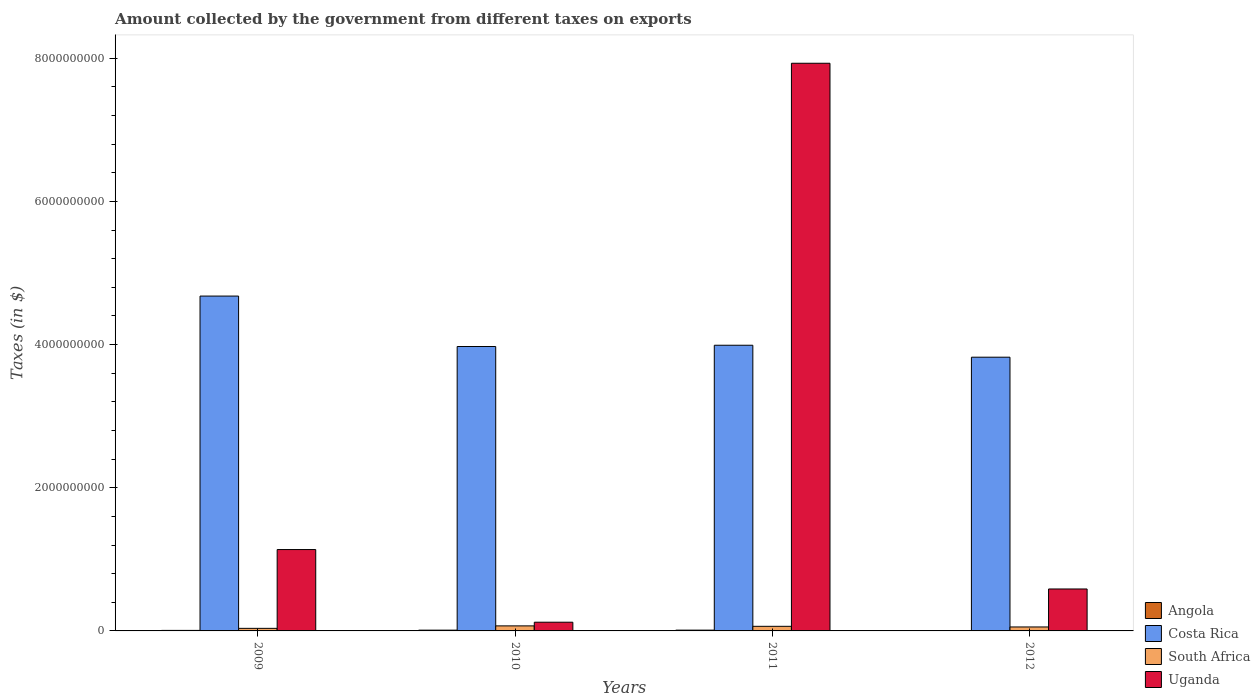How many groups of bars are there?
Offer a terse response. 4. Are the number of bars per tick equal to the number of legend labels?
Offer a very short reply. Yes. Are the number of bars on each tick of the X-axis equal?
Provide a succinct answer. Yes. How many bars are there on the 4th tick from the left?
Your response must be concise. 4. What is the label of the 2nd group of bars from the left?
Make the answer very short. 2010. In how many cases, is the number of bars for a given year not equal to the number of legend labels?
Keep it short and to the point. 0. What is the amount collected by the government from taxes on exports in South Africa in 2010?
Offer a very short reply. 7.04e+07. Across all years, what is the maximum amount collected by the government from taxes on exports in Angola?
Offer a very short reply. 1.11e+07. Across all years, what is the minimum amount collected by the government from taxes on exports in Angola?
Provide a short and direct response. 4.42e+05. In which year was the amount collected by the government from taxes on exports in South Africa maximum?
Ensure brevity in your answer.  2010. In which year was the amount collected by the government from taxes on exports in Angola minimum?
Keep it short and to the point. 2012. What is the total amount collected by the government from taxes on exports in Uganda in the graph?
Give a very brief answer. 9.77e+09. What is the difference between the amount collected by the government from taxes on exports in Costa Rica in 2009 and that in 2012?
Keep it short and to the point. 8.54e+08. What is the difference between the amount collected by the government from taxes on exports in South Africa in 2011 and the amount collected by the government from taxes on exports in Costa Rica in 2010?
Offer a terse response. -3.91e+09. What is the average amount collected by the government from taxes on exports in South Africa per year?
Provide a short and direct response. 5.65e+07. In the year 2009, what is the difference between the amount collected by the government from taxes on exports in Costa Rica and amount collected by the government from taxes on exports in South Africa?
Make the answer very short. 4.64e+09. In how many years, is the amount collected by the government from taxes on exports in Uganda greater than 5600000000 $?
Your answer should be compact. 1. What is the ratio of the amount collected by the government from taxes on exports in Uganda in 2010 to that in 2011?
Offer a very short reply. 0.02. What is the difference between the highest and the second highest amount collected by the government from taxes on exports in Angola?
Make the answer very short. 4.03e+05. What is the difference between the highest and the lowest amount collected by the government from taxes on exports in Costa Rica?
Your answer should be compact. 8.54e+08. Is it the case that in every year, the sum of the amount collected by the government from taxes on exports in Costa Rica and amount collected by the government from taxes on exports in South Africa is greater than the sum of amount collected by the government from taxes on exports in Angola and amount collected by the government from taxes on exports in Uganda?
Provide a short and direct response. Yes. What does the 1st bar from the left in 2011 represents?
Provide a short and direct response. Angola. What does the 1st bar from the right in 2012 represents?
Make the answer very short. Uganda. Are all the bars in the graph horizontal?
Your answer should be very brief. No. Are the values on the major ticks of Y-axis written in scientific E-notation?
Your response must be concise. No. Where does the legend appear in the graph?
Ensure brevity in your answer.  Bottom right. How many legend labels are there?
Provide a short and direct response. 4. How are the legend labels stacked?
Your answer should be very brief. Vertical. What is the title of the graph?
Your response must be concise. Amount collected by the government from different taxes on exports. What is the label or title of the Y-axis?
Offer a terse response. Taxes (in $). What is the Taxes (in $) of Angola in 2009?
Your answer should be very brief. 7.26e+06. What is the Taxes (in $) of Costa Rica in 2009?
Offer a terse response. 4.68e+09. What is the Taxes (in $) of South Africa in 2009?
Provide a succinct answer. 3.60e+07. What is the Taxes (in $) in Uganda in 2009?
Offer a terse response. 1.14e+09. What is the Taxes (in $) in Angola in 2010?
Offer a very short reply. 1.07e+07. What is the Taxes (in $) of Costa Rica in 2010?
Provide a short and direct response. 3.97e+09. What is the Taxes (in $) in South Africa in 2010?
Make the answer very short. 7.04e+07. What is the Taxes (in $) in Uganda in 2010?
Give a very brief answer. 1.22e+08. What is the Taxes (in $) of Angola in 2011?
Provide a short and direct response. 1.11e+07. What is the Taxes (in $) of Costa Rica in 2011?
Provide a succinct answer. 3.99e+09. What is the Taxes (in $) in South Africa in 2011?
Offer a very short reply. 6.42e+07. What is the Taxes (in $) in Uganda in 2011?
Make the answer very short. 7.93e+09. What is the Taxes (in $) of Angola in 2012?
Your answer should be compact. 4.42e+05. What is the Taxes (in $) of Costa Rica in 2012?
Your answer should be compact. 3.82e+09. What is the Taxes (in $) of South Africa in 2012?
Provide a short and direct response. 5.54e+07. What is the Taxes (in $) of Uganda in 2012?
Provide a short and direct response. 5.86e+08. Across all years, what is the maximum Taxes (in $) in Angola?
Your answer should be very brief. 1.11e+07. Across all years, what is the maximum Taxes (in $) of Costa Rica?
Provide a short and direct response. 4.68e+09. Across all years, what is the maximum Taxes (in $) in South Africa?
Your response must be concise. 7.04e+07. Across all years, what is the maximum Taxes (in $) in Uganda?
Keep it short and to the point. 7.93e+09. Across all years, what is the minimum Taxes (in $) in Angola?
Give a very brief answer. 4.42e+05. Across all years, what is the minimum Taxes (in $) of Costa Rica?
Offer a terse response. 3.82e+09. Across all years, what is the minimum Taxes (in $) of South Africa?
Keep it short and to the point. 3.60e+07. Across all years, what is the minimum Taxes (in $) of Uganda?
Your response must be concise. 1.22e+08. What is the total Taxes (in $) of Angola in the graph?
Provide a short and direct response. 2.95e+07. What is the total Taxes (in $) of Costa Rica in the graph?
Offer a terse response. 1.65e+1. What is the total Taxes (in $) in South Africa in the graph?
Keep it short and to the point. 2.26e+08. What is the total Taxes (in $) in Uganda in the graph?
Your response must be concise. 9.77e+09. What is the difference between the Taxes (in $) of Angola in 2009 and that in 2010?
Offer a terse response. -3.46e+06. What is the difference between the Taxes (in $) of Costa Rica in 2009 and that in 2010?
Make the answer very short. 7.04e+08. What is the difference between the Taxes (in $) of South Africa in 2009 and that in 2010?
Keep it short and to the point. -3.44e+07. What is the difference between the Taxes (in $) of Uganda in 2009 and that in 2010?
Your answer should be very brief. 1.01e+09. What is the difference between the Taxes (in $) of Angola in 2009 and that in 2011?
Your response must be concise. -3.86e+06. What is the difference between the Taxes (in $) of Costa Rica in 2009 and that in 2011?
Provide a succinct answer. 6.87e+08. What is the difference between the Taxes (in $) in South Africa in 2009 and that in 2011?
Offer a very short reply. -2.82e+07. What is the difference between the Taxes (in $) in Uganda in 2009 and that in 2011?
Provide a succinct answer. -6.79e+09. What is the difference between the Taxes (in $) in Angola in 2009 and that in 2012?
Offer a terse response. 6.82e+06. What is the difference between the Taxes (in $) in Costa Rica in 2009 and that in 2012?
Make the answer very short. 8.54e+08. What is the difference between the Taxes (in $) in South Africa in 2009 and that in 2012?
Your response must be concise. -1.94e+07. What is the difference between the Taxes (in $) in Uganda in 2009 and that in 2012?
Your answer should be very brief. 5.51e+08. What is the difference between the Taxes (in $) of Angola in 2010 and that in 2011?
Ensure brevity in your answer.  -4.03e+05. What is the difference between the Taxes (in $) of Costa Rica in 2010 and that in 2011?
Your response must be concise. -1.76e+07. What is the difference between the Taxes (in $) in South Africa in 2010 and that in 2011?
Provide a succinct answer. 6.16e+06. What is the difference between the Taxes (in $) in Uganda in 2010 and that in 2011?
Your response must be concise. -7.81e+09. What is the difference between the Taxes (in $) in Angola in 2010 and that in 2012?
Your answer should be compact. 1.03e+07. What is the difference between the Taxes (in $) in Costa Rica in 2010 and that in 2012?
Your answer should be very brief. 1.49e+08. What is the difference between the Taxes (in $) in South Africa in 2010 and that in 2012?
Give a very brief answer. 1.50e+07. What is the difference between the Taxes (in $) in Uganda in 2010 and that in 2012?
Provide a short and direct response. -4.64e+08. What is the difference between the Taxes (in $) in Angola in 2011 and that in 2012?
Give a very brief answer. 1.07e+07. What is the difference between the Taxes (in $) of Costa Rica in 2011 and that in 2012?
Ensure brevity in your answer.  1.67e+08. What is the difference between the Taxes (in $) in South Africa in 2011 and that in 2012?
Your response must be concise. 8.85e+06. What is the difference between the Taxes (in $) of Uganda in 2011 and that in 2012?
Your response must be concise. 7.34e+09. What is the difference between the Taxes (in $) in Angola in 2009 and the Taxes (in $) in Costa Rica in 2010?
Provide a short and direct response. -3.97e+09. What is the difference between the Taxes (in $) in Angola in 2009 and the Taxes (in $) in South Africa in 2010?
Ensure brevity in your answer.  -6.31e+07. What is the difference between the Taxes (in $) of Angola in 2009 and the Taxes (in $) of Uganda in 2010?
Offer a very short reply. -1.15e+08. What is the difference between the Taxes (in $) of Costa Rica in 2009 and the Taxes (in $) of South Africa in 2010?
Provide a succinct answer. 4.61e+09. What is the difference between the Taxes (in $) in Costa Rica in 2009 and the Taxes (in $) in Uganda in 2010?
Provide a succinct answer. 4.56e+09. What is the difference between the Taxes (in $) of South Africa in 2009 and the Taxes (in $) of Uganda in 2010?
Ensure brevity in your answer.  -8.58e+07. What is the difference between the Taxes (in $) of Angola in 2009 and the Taxes (in $) of Costa Rica in 2011?
Offer a terse response. -3.98e+09. What is the difference between the Taxes (in $) of Angola in 2009 and the Taxes (in $) of South Africa in 2011?
Your answer should be compact. -5.70e+07. What is the difference between the Taxes (in $) in Angola in 2009 and the Taxes (in $) in Uganda in 2011?
Provide a short and direct response. -7.92e+09. What is the difference between the Taxes (in $) in Costa Rica in 2009 and the Taxes (in $) in South Africa in 2011?
Offer a very short reply. 4.61e+09. What is the difference between the Taxes (in $) of Costa Rica in 2009 and the Taxes (in $) of Uganda in 2011?
Offer a terse response. -3.25e+09. What is the difference between the Taxes (in $) in South Africa in 2009 and the Taxes (in $) in Uganda in 2011?
Give a very brief answer. -7.89e+09. What is the difference between the Taxes (in $) of Angola in 2009 and the Taxes (in $) of Costa Rica in 2012?
Offer a very short reply. -3.82e+09. What is the difference between the Taxes (in $) of Angola in 2009 and the Taxes (in $) of South Africa in 2012?
Provide a succinct answer. -4.81e+07. What is the difference between the Taxes (in $) of Angola in 2009 and the Taxes (in $) of Uganda in 2012?
Offer a very short reply. -5.79e+08. What is the difference between the Taxes (in $) in Costa Rica in 2009 and the Taxes (in $) in South Africa in 2012?
Ensure brevity in your answer.  4.62e+09. What is the difference between the Taxes (in $) in Costa Rica in 2009 and the Taxes (in $) in Uganda in 2012?
Your answer should be very brief. 4.09e+09. What is the difference between the Taxes (in $) of South Africa in 2009 and the Taxes (in $) of Uganda in 2012?
Make the answer very short. -5.50e+08. What is the difference between the Taxes (in $) of Angola in 2010 and the Taxes (in $) of Costa Rica in 2011?
Keep it short and to the point. -3.98e+09. What is the difference between the Taxes (in $) of Angola in 2010 and the Taxes (in $) of South Africa in 2011?
Offer a very short reply. -5.35e+07. What is the difference between the Taxes (in $) of Angola in 2010 and the Taxes (in $) of Uganda in 2011?
Provide a short and direct response. -7.92e+09. What is the difference between the Taxes (in $) of Costa Rica in 2010 and the Taxes (in $) of South Africa in 2011?
Give a very brief answer. 3.91e+09. What is the difference between the Taxes (in $) in Costa Rica in 2010 and the Taxes (in $) in Uganda in 2011?
Your response must be concise. -3.96e+09. What is the difference between the Taxes (in $) of South Africa in 2010 and the Taxes (in $) of Uganda in 2011?
Offer a terse response. -7.86e+09. What is the difference between the Taxes (in $) in Angola in 2010 and the Taxes (in $) in Costa Rica in 2012?
Your answer should be compact. -3.81e+09. What is the difference between the Taxes (in $) of Angola in 2010 and the Taxes (in $) of South Africa in 2012?
Your response must be concise. -4.47e+07. What is the difference between the Taxes (in $) of Angola in 2010 and the Taxes (in $) of Uganda in 2012?
Provide a short and direct response. -5.75e+08. What is the difference between the Taxes (in $) in Costa Rica in 2010 and the Taxes (in $) in South Africa in 2012?
Provide a short and direct response. 3.92e+09. What is the difference between the Taxes (in $) of Costa Rica in 2010 and the Taxes (in $) of Uganda in 2012?
Offer a terse response. 3.39e+09. What is the difference between the Taxes (in $) in South Africa in 2010 and the Taxes (in $) in Uganda in 2012?
Offer a terse response. -5.16e+08. What is the difference between the Taxes (in $) of Angola in 2011 and the Taxes (in $) of Costa Rica in 2012?
Make the answer very short. -3.81e+09. What is the difference between the Taxes (in $) of Angola in 2011 and the Taxes (in $) of South Africa in 2012?
Provide a succinct answer. -4.43e+07. What is the difference between the Taxes (in $) in Angola in 2011 and the Taxes (in $) in Uganda in 2012?
Offer a very short reply. -5.75e+08. What is the difference between the Taxes (in $) in Costa Rica in 2011 and the Taxes (in $) in South Africa in 2012?
Ensure brevity in your answer.  3.94e+09. What is the difference between the Taxes (in $) of Costa Rica in 2011 and the Taxes (in $) of Uganda in 2012?
Your answer should be very brief. 3.40e+09. What is the difference between the Taxes (in $) of South Africa in 2011 and the Taxes (in $) of Uganda in 2012?
Ensure brevity in your answer.  -5.22e+08. What is the average Taxes (in $) in Angola per year?
Your answer should be compact. 7.38e+06. What is the average Taxes (in $) in Costa Rica per year?
Provide a succinct answer. 4.12e+09. What is the average Taxes (in $) of South Africa per year?
Your response must be concise. 5.65e+07. What is the average Taxes (in $) in Uganda per year?
Your answer should be very brief. 2.44e+09. In the year 2009, what is the difference between the Taxes (in $) of Angola and Taxes (in $) of Costa Rica?
Give a very brief answer. -4.67e+09. In the year 2009, what is the difference between the Taxes (in $) of Angola and Taxes (in $) of South Africa?
Offer a very short reply. -2.87e+07. In the year 2009, what is the difference between the Taxes (in $) in Angola and Taxes (in $) in Uganda?
Offer a terse response. -1.13e+09. In the year 2009, what is the difference between the Taxes (in $) in Costa Rica and Taxes (in $) in South Africa?
Your answer should be very brief. 4.64e+09. In the year 2009, what is the difference between the Taxes (in $) of Costa Rica and Taxes (in $) of Uganda?
Your response must be concise. 3.54e+09. In the year 2009, what is the difference between the Taxes (in $) in South Africa and Taxes (in $) in Uganda?
Make the answer very short. -1.10e+09. In the year 2010, what is the difference between the Taxes (in $) of Angola and Taxes (in $) of Costa Rica?
Your response must be concise. -3.96e+09. In the year 2010, what is the difference between the Taxes (in $) of Angola and Taxes (in $) of South Africa?
Provide a short and direct response. -5.97e+07. In the year 2010, what is the difference between the Taxes (in $) in Angola and Taxes (in $) in Uganda?
Your response must be concise. -1.11e+08. In the year 2010, what is the difference between the Taxes (in $) in Costa Rica and Taxes (in $) in South Africa?
Keep it short and to the point. 3.90e+09. In the year 2010, what is the difference between the Taxes (in $) of Costa Rica and Taxes (in $) of Uganda?
Offer a terse response. 3.85e+09. In the year 2010, what is the difference between the Taxes (in $) of South Africa and Taxes (in $) of Uganda?
Your answer should be compact. -5.14e+07. In the year 2011, what is the difference between the Taxes (in $) of Angola and Taxes (in $) of Costa Rica?
Ensure brevity in your answer.  -3.98e+09. In the year 2011, what is the difference between the Taxes (in $) in Angola and Taxes (in $) in South Africa?
Provide a short and direct response. -5.31e+07. In the year 2011, what is the difference between the Taxes (in $) of Angola and Taxes (in $) of Uganda?
Your answer should be compact. -7.92e+09. In the year 2011, what is the difference between the Taxes (in $) of Costa Rica and Taxes (in $) of South Africa?
Your answer should be compact. 3.93e+09. In the year 2011, what is the difference between the Taxes (in $) in Costa Rica and Taxes (in $) in Uganda?
Offer a very short reply. -3.94e+09. In the year 2011, what is the difference between the Taxes (in $) of South Africa and Taxes (in $) of Uganda?
Make the answer very short. -7.87e+09. In the year 2012, what is the difference between the Taxes (in $) in Angola and Taxes (in $) in Costa Rica?
Offer a very short reply. -3.82e+09. In the year 2012, what is the difference between the Taxes (in $) in Angola and Taxes (in $) in South Africa?
Keep it short and to the point. -5.49e+07. In the year 2012, what is the difference between the Taxes (in $) of Angola and Taxes (in $) of Uganda?
Make the answer very short. -5.85e+08. In the year 2012, what is the difference between the Taxes (in $) of Costa Rica and Taxes (in $) of South Africa?
Your answer should be very brief. 3.77e+09. In the year 2012, what is the difference between the Taxes (in $) of Costa Rica and Taxes (in $) of Uganda?
Your response must be concise. 3.24e+09. In the year 2012, what is the difference between the Taxes (in $) in South Africa and Taxes (in $) in Uganda?
Your response must be concise. -5.31e+08. What is the ratio of the Taxes (in $) in Angola in 2009 to that in 2010?
Keep it short and to the point. 0.68. What is the ratio of the Taxes (in $) in Costa Rica in 2009 to that in 2010?
Make the answer very short. 1.18. What is the ratio of the Taxes (in $) in South Africa in 2009 to that in 2010?
Make the answer very short. 0.51. What is the ratio of the Taxes (in $) in Uganda in 2009 to that in 2010?
Give a very brief answer. 9.33. What is the ratio of the Taxes (in $) in Angola in 2009 to that in 2011?
Offer a very short reply. 0.65. What is the ratio of the Taxes (in $) of Costa Rica in 2009 to that in 2011?
Your response must be concise. 1.17. What is the ratio of the Taxes (in $) of South Africa in 2009 to that in 2011?
Provide a succinct answer. 0.56. What is the ratio of the Taxes (in $) of Uganda in 2009 to that in 2011?
Make the answer very short. 0.14. What is the ratio of the Taxes (in $) in Angola in 2009 to that in 2012?
Your response must be concise. 16.42. What is the ratio of the Taxes (in $) of Costa Rica in 2009 to that in 2012?
Provide a succinct answer. 1.22. What is the ratio of the Taxes (in $) of South Africa in 2009 to that in 2012?
Ensure brevity in your answer.  0.65. What is the ratio of the Taxes (in $) in Uganda in 2009 to that in 2012?
Make the answer very short. 1.94. What is the ratio of the Taxes (in $) in Angola in 2010 to that in 2011?
Your response must be concise. 0.96. What is the ratio of the Taxes (in $) in South Africa in 2010 to that in 2011?
Your response must be concise. 1.1. What is the ratio of the Taxes (in $) of Uganda in 2010 to that in 2011?
Your response must be concise. 0.02. What is the ratio of the Taxes (in $) in Angola in 2010 to that in 2012?
Make the answer very short. 24.23. What is the ratio of the Taxes (in $) of Costa Rica in 2010 to that in 2012?
Offer a very short reply. 1.04. What is the ratio of the Taxes (in $) in South Africa in 2010 to that in 2012?
Ensure brevity in your answer.  1.27. What is the ratio of the Taxes (in $) of Uganda in 2010 to that in 2012?
Provide a succinct answer. 0.21. What is the ratio of the Taxes (in $) of Angola in 2011 to that in 2012?
Keep it short and to the point. 25.14. What is the ratio of the Taxes (in $) in Costa Rica in 2011 to that in 2012?
Ensure brevity in your answer.  1.04. What is the ratio of the Taxes (in $) in South Africa in 2011 to that in 2012?
Provide a succinct answer. 1.16. What is the ratio of the Taxes (in $) in Uganda in 2011 to that in 2012?
Offer a terse response. 13.53. What is the difference between the highest and the second highest Taxes (in $) in Angola?
Give a very brief answer. 4.03e+05. What is the difference between the highest and the second highest Taxes (in $) in Costa Rica?
Ensure brevity in your answer.  6.87e+08. What is the difference between the highest and the second highest Taxes (in $) of South Africa?
Provide a short and direct response. 6.16e+06. What is the difference between the highest and the second highest Taxes (in $) of Uganda?
Keep it short and to the point. 6.79e+09. What is the difference between the highest and the lowest Taxes (in $) of Angola?
Your answer should be compact. 1.07e+07. What is the difference between the highest and the lowest Taxes (in $) of Costa Rica?
Give a very brief answer. 8.54e+08. What is the difference between the highest and the lowest Taxes (in $) in South Africa?
Your answer should be compact. 3.44e+07. What is the difference between the highest and the lowest Taxes (in $) of Uganda?
Give a very brief answer. 7.81e+09. 